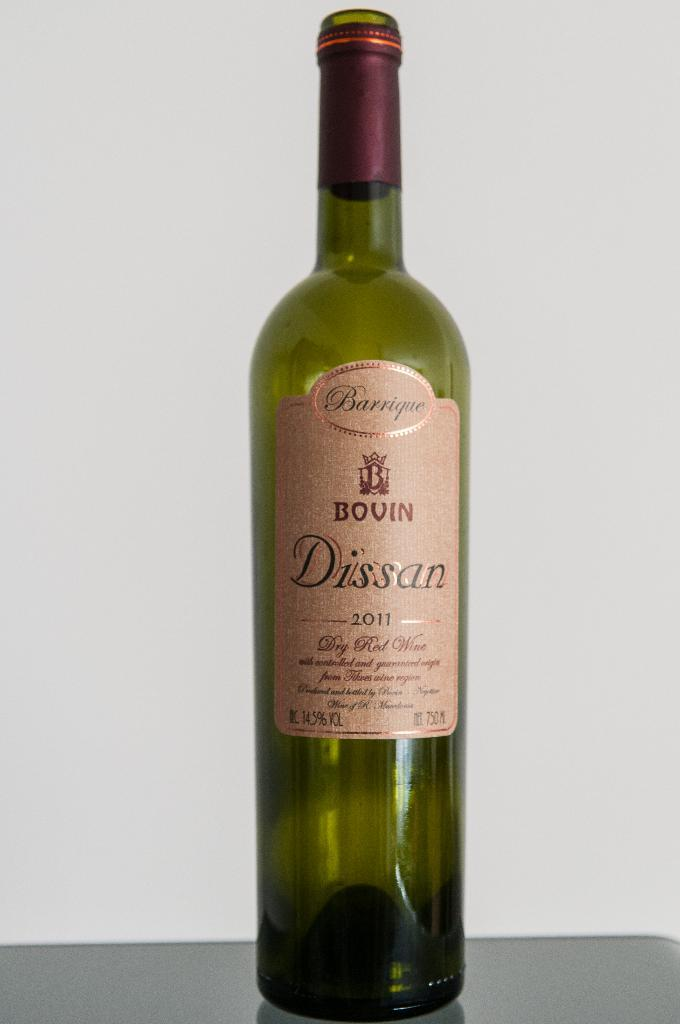<image>
Present a compact description of the photo's key features. Long wine bottle with a label which says it is from 2011. 